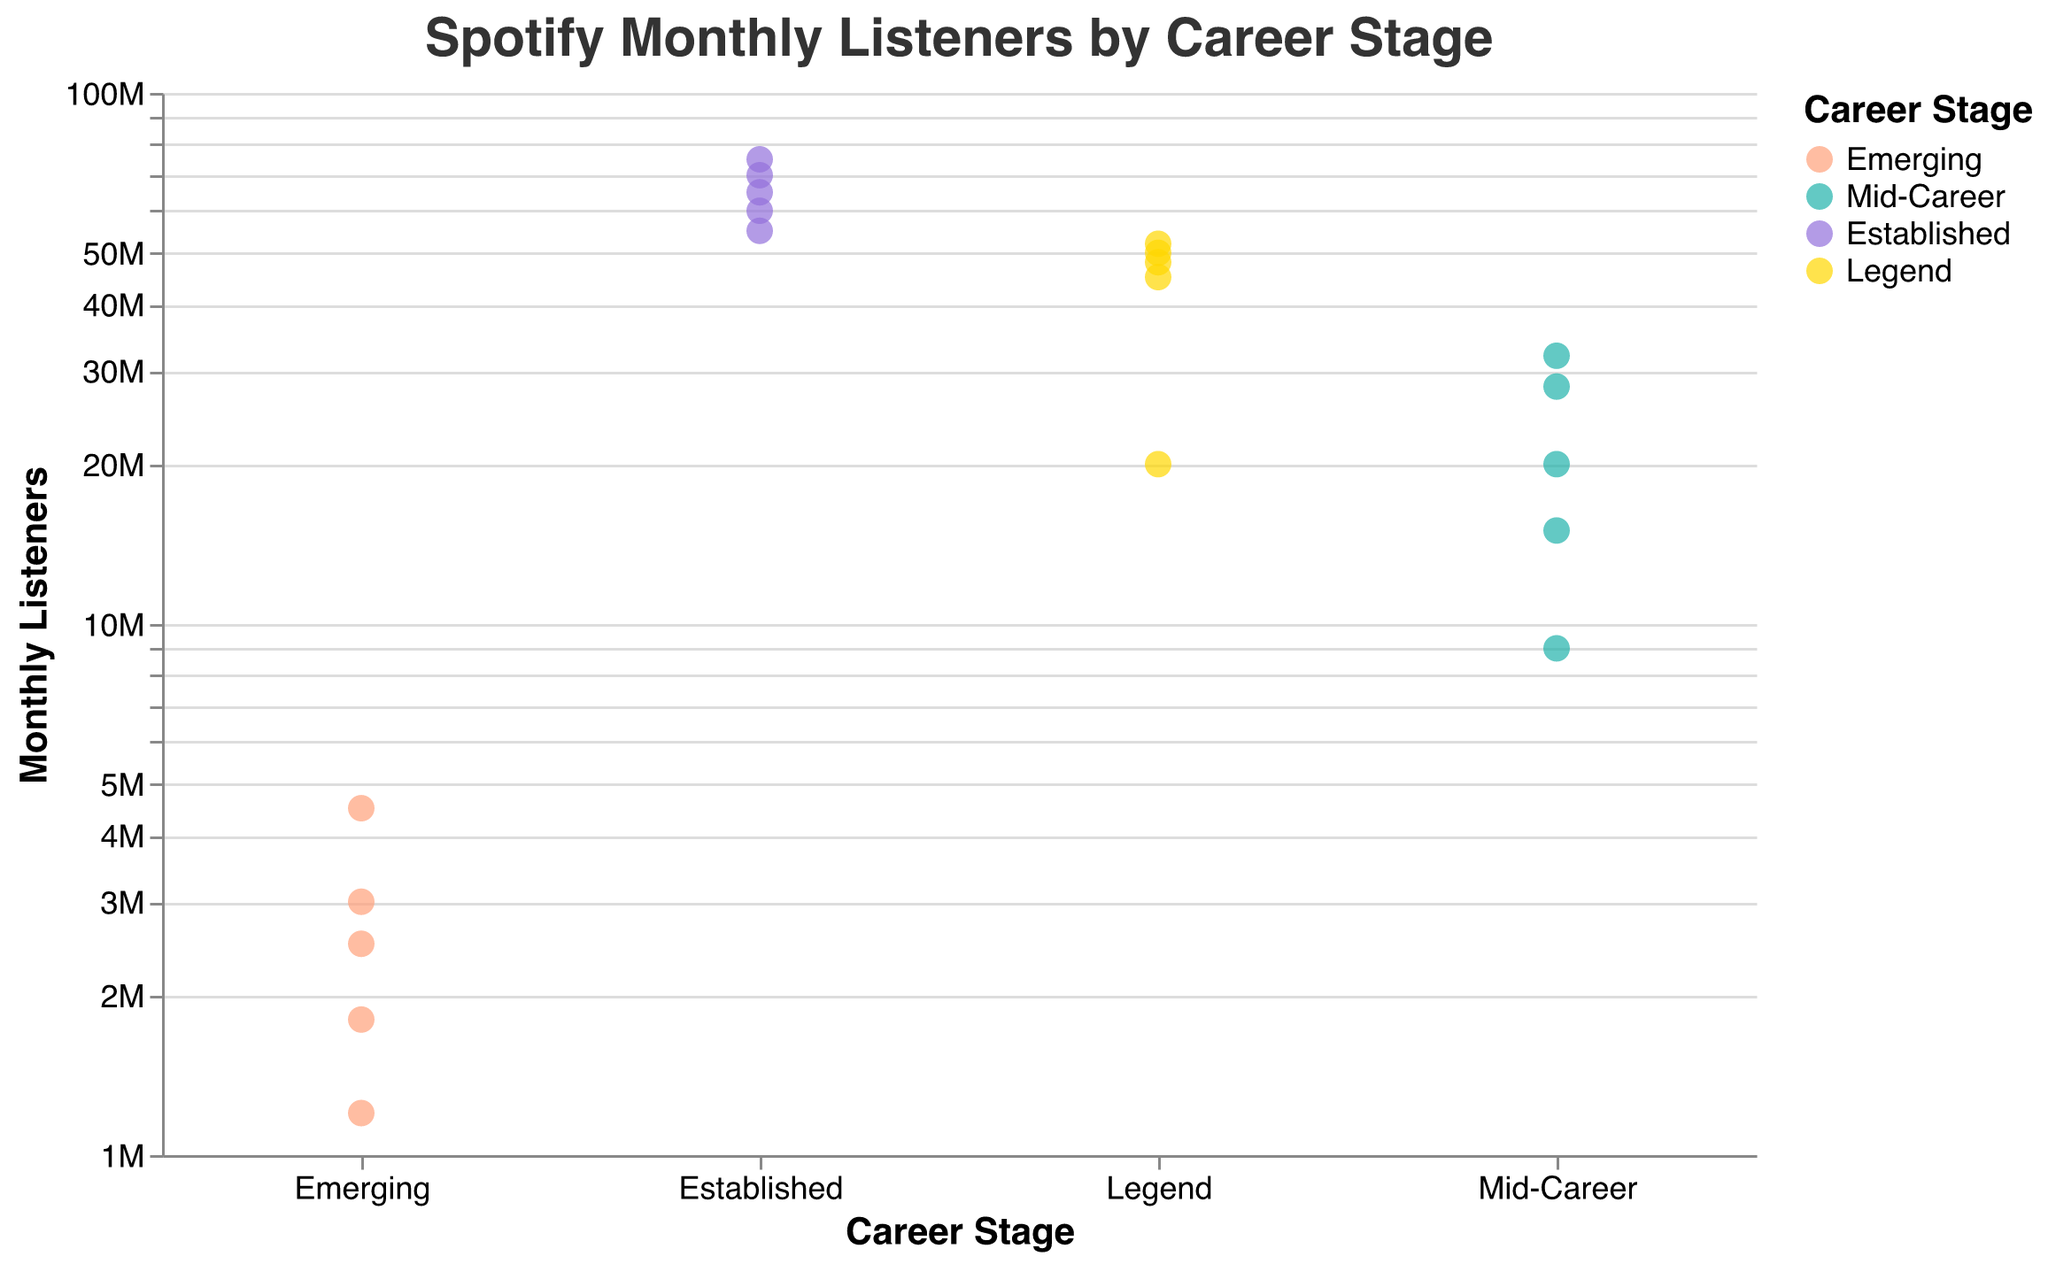What's the title of the figure? The title of the figure is usually placed at the top of the chart and describes the content of the figure. In this case, it's "Spotify Monthly Listeners by Career Stage."
Answer: Spotify Monthly Listeners by Career Stage What axis represents the monthly listeners? The y-axis usually holds the quantitative values in a chart like a strip plot. In this case, it is labeled "Monthly Listeners."
Answer: y-axis What is the color associated with the "Established" career stage? The color legend on the right side of the chart links each career stage to a specific color. The "Established" career stage is represented by a purple color.
Answer: purple How many artists are in the "Emerging" career stage? The x-axis labels the different career stages, and the points above those labels represent the number of artists. Counting the dots, we see there are five points under the "Emerging" category.
Answer: 5 Which artist in the "Mid-Career" stage has the highest monthly listeners? By looking at the points above the "Mid-Career" label and checking their y-values, we identify that Halsey has the highest monthly listeners at 32,000,000.
Answer: Halsey What is the range of monthly listeners for artists in the "Legend" stage? First, identify the minimum and maximum monthly listener values in the "Legend" stage. The lowest is Madonna with 20,000,000 and the highest is Eminem with 52,000,000. The range is calculated as 52,000,000 - 20,000,000 = 32,000,000.
Answer: 32,000,000 Which career stage includes the artist with the highest monthly listeners? The artist with the highest monthly listeners is Ed Sheeran with 75,000,000. He belongs to the "Established" career stage.
Answer: Established How does the average monthly listeners for the "Mid-Career" stage compare to the "Emerging" stage? For "Mid-Career," sum the listeners (15M + 9M + 28M + 20M + 32M = 104M) and then divide by 5, averaging to 20.8M. For "Emerging," sum the listeners (2.5M + 1.8M + 1.2M + 3M + 4.5M = 13M) and then divide by 5, averaging to 2.6M. Therefore, the average of the "Mid-Career" stage is significantly higher than the "Emerging" stage.
Answer: Mid-Career average is higher Which artist has more monthly listeners, Coldplay or Justin Bieber? By looking at the data points or tooltips, Coldplay has 50 million listeners, and Justin Bieber has 70 million listeners. Therefore, Justin Bieber has more monthly listeners.
Answer: Justin Bieber 